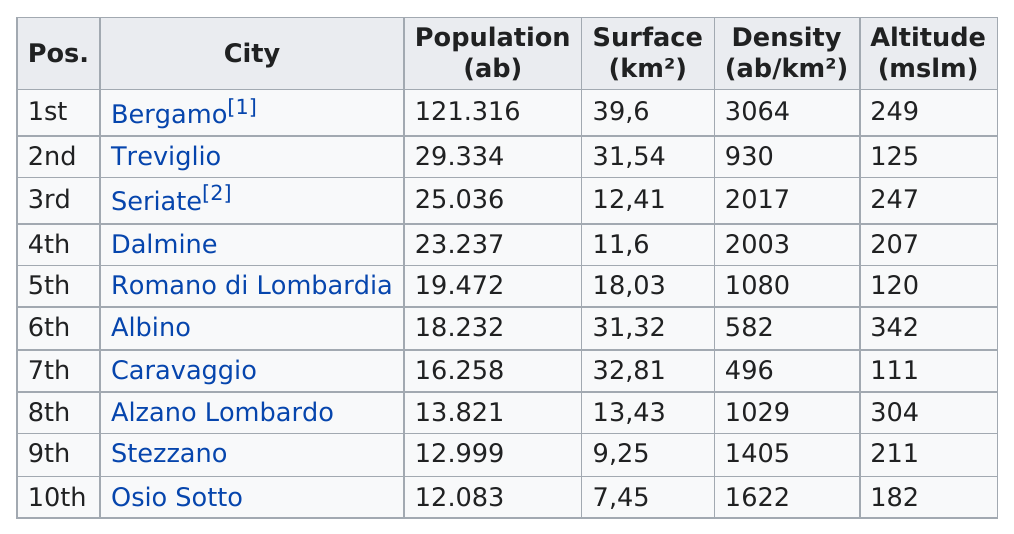Specify some key components in this picture. The highest city in terms of altitude is Albino. Bergamo is the city with the largest population. The last city listed on this chart is Osio Sotto. Osio Sotto is the city with the least amount of surface area. There are 10 cities depicted on this chart. 